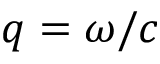Convert formula to latex. <formula><loc_0><loc_0><loc_500><loc_500>q = \omega / c</formula> 